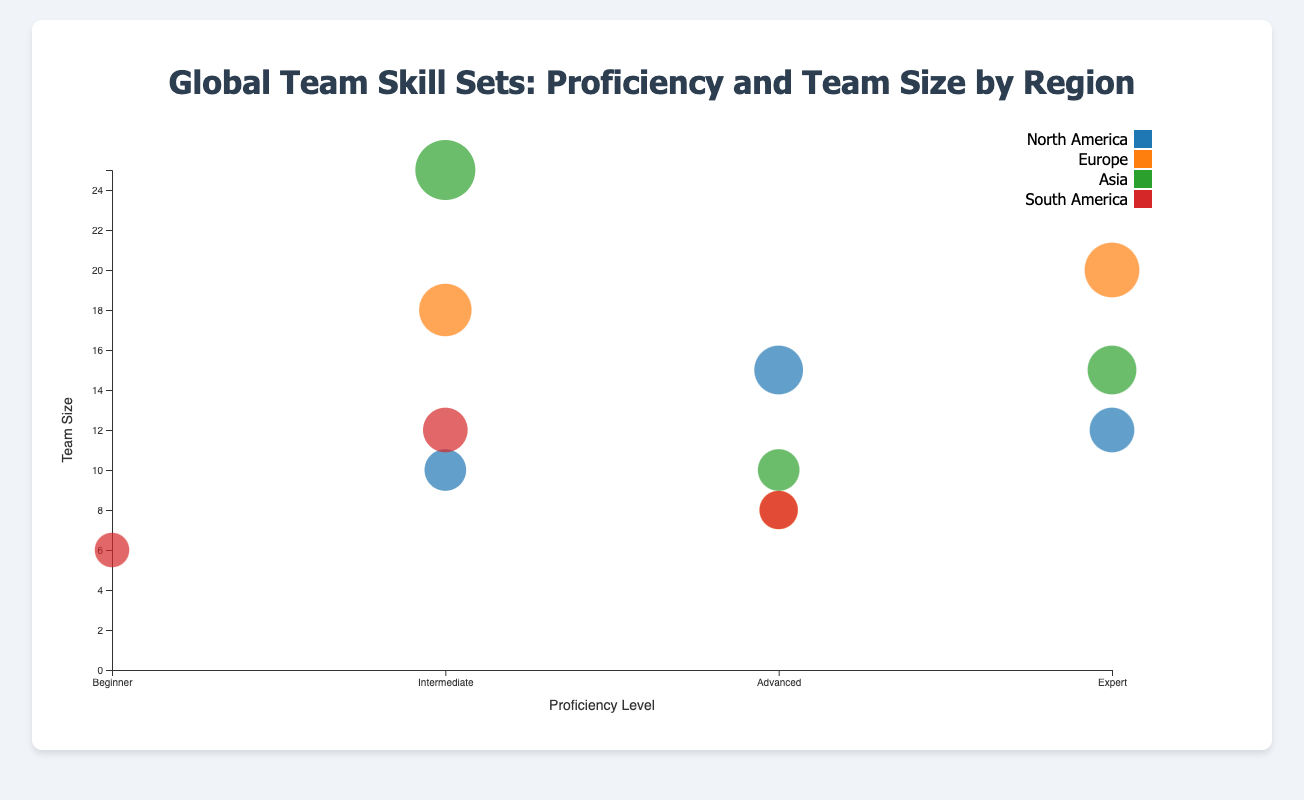Which region has the largest team size for Software Development? To determine this, look at the bubble sizes for Software Development across all regions. Asia has the largest bubble for Software Development, representing the largest team size.
Answer: Asia What is the proficiency level of Data Analysis in North America? Check the position (x-axis) of the bubble representing Data Analysis in the North America region. The bubble is on the "Expert" level.
Answer: Expert How many proficiency levels are represented in the chart? Examine the x-axis, which lists the proficiency levels. There are four levels: Beginner, Intermediate, Advanced, and Expert.
Answer: 4 Which region has the highest proficiency level for Cloud Computing? Observe the x-axis positioning of the bubbles representing Cloud Computing. The Asia region bubble for Cloud Computing is positioned at the "Expert" level, which is the highest.
Answer: Asia Compare the team size for Project Management between North America and South America. The bubbles for Project Management in both regions show different sizes. North America's bubble size represents 10 members, and South America's bubble size represents 12 members, so South America has a larger size.
Answer: South America Which skill has the smallest team size in South America? Look at the bubble sizes within the South America region for the smallest bubble. The smallest bubble represents Data Analysis with a team size of 6.
Answer: Data Analysis What is the median team size for data analysis across all regions? Sort the team sizes for Data Analysis: 6 (South America), 12 (North America), 18 (Europe). Since there are three team sizes, the median is 18.
Answer: 18 Are there any regions without representation in Cybersecurity? Examine the bubbles and notice that only Asia has a bubble for Cybersecurity, indicating that North America, Europe, and South America have no representation.
Answer: Yes Which skill has the highest proficiency in Europe, and what is its team size? Check the bubbles in Europe and identify the one at the "Expert" level. The skill is Software Development with a team size of 20.
Answer: Software Development, 20 What is the color representing the Asia region in the chart legend? Refer to the legend on the chart to identify the color assigned to Asia.
Answer: Answer depends on the color scheme used, typically a distinct color like red or blue 